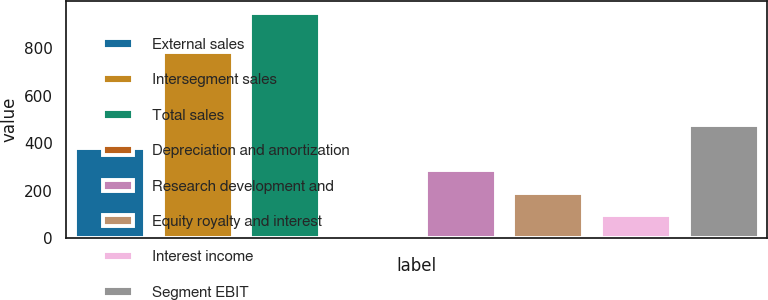Convert chart to OTSL. <chart><loc_0><loc_0><loc_500><loc_500><bar_chart><fcel>External sales<fcel>Intersegment sales<fcel>Total sales<fcel>Depreciation and amortization<fcel>Research development and<fcel>Equity royalty and interest<fcel>Interest income<fcel>Segment EBIT<nl><fcel>380.8<fcel>782<fcel>949<fcel>2<fcel>286.1<fcel>191.4<fcel>96.7<fcel>475.5<nl></chart> 